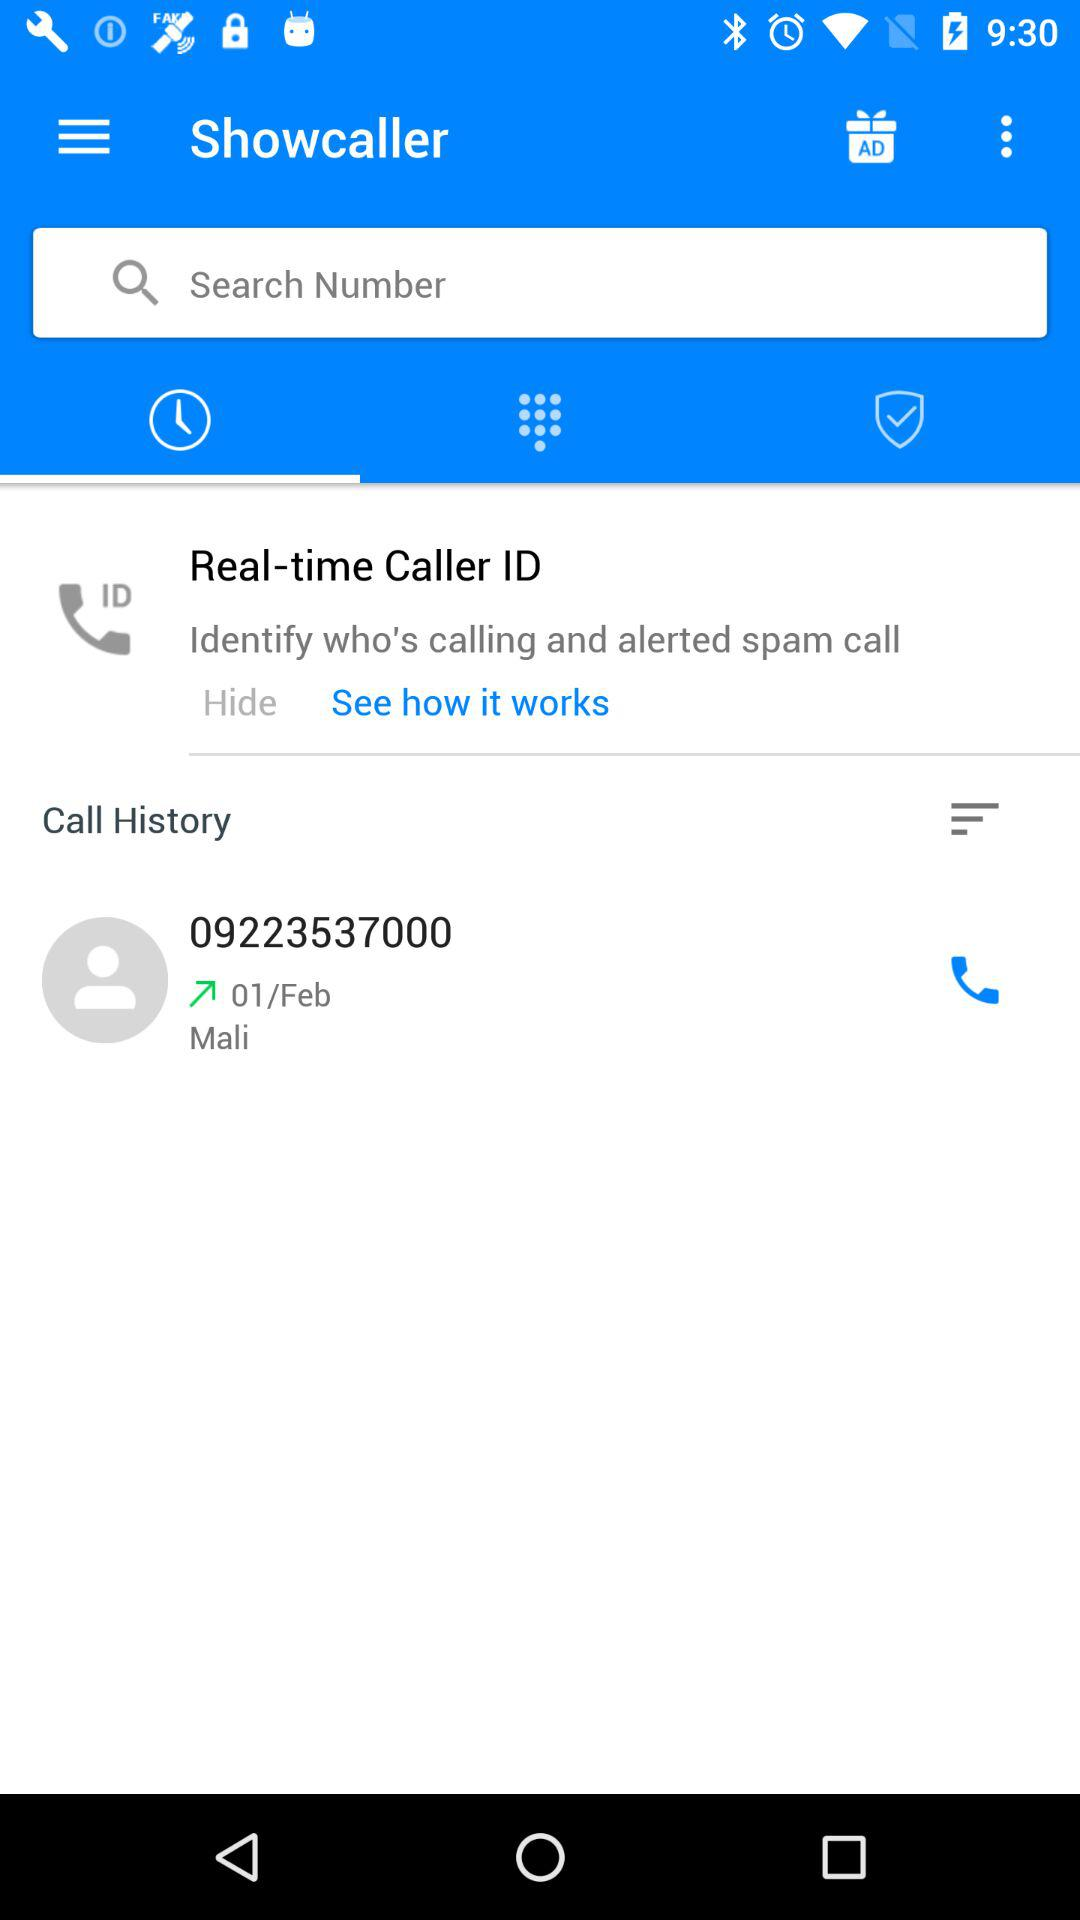What is the date of the call in the call history? The date of the call in the call history is February 1. 